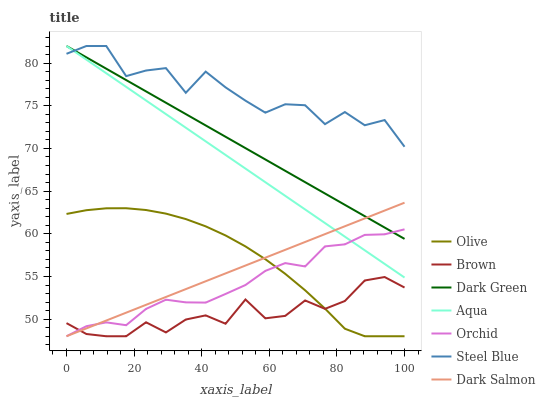Does Brown have the minimum area under the curve?
Answer yes or no. Yes. Does Steel Blue have the maximum area under the curve?
Answer yes or no. Yes. Does Aqua have the minimum area under the curve?
Answer yes or no. No. Does Aqua have the maximum area under the curve?
Answer yes or no. No. Is Dark Salmon the smoothest?
Answer yes or no. Yes. Is Steel Blue the roughest?
Answer yes or no. Yes. Is Aqua the smoothest?
Answer yes or no. No. Is Aqua the roughest?
Answer yes or no. No. Does Brown have the lowest value?
Answer yes or no. Yes. Does Aqua have the lowest value?
Answer yes or no. No. Does Dark Green have the highest value?
Answer yes or no. Yes. Does Dark Salmon have the highest value?
Answer yes or no. No. Is Brown less than Aqua?
Answer yes or no. Yes. Is Steel Blue greater than Olive?
Answer yes or no. Yes. Does Orchid intersect Dark Salmon?
Answer yes or no. Yes. Is Orchid less than Dark Salmon?
Answer yes or no. No. Is Orchid greater than Dark Salmon?
Answer yes or no. No. Does Brown intersect Aqua?
Answer yes or no. No. 